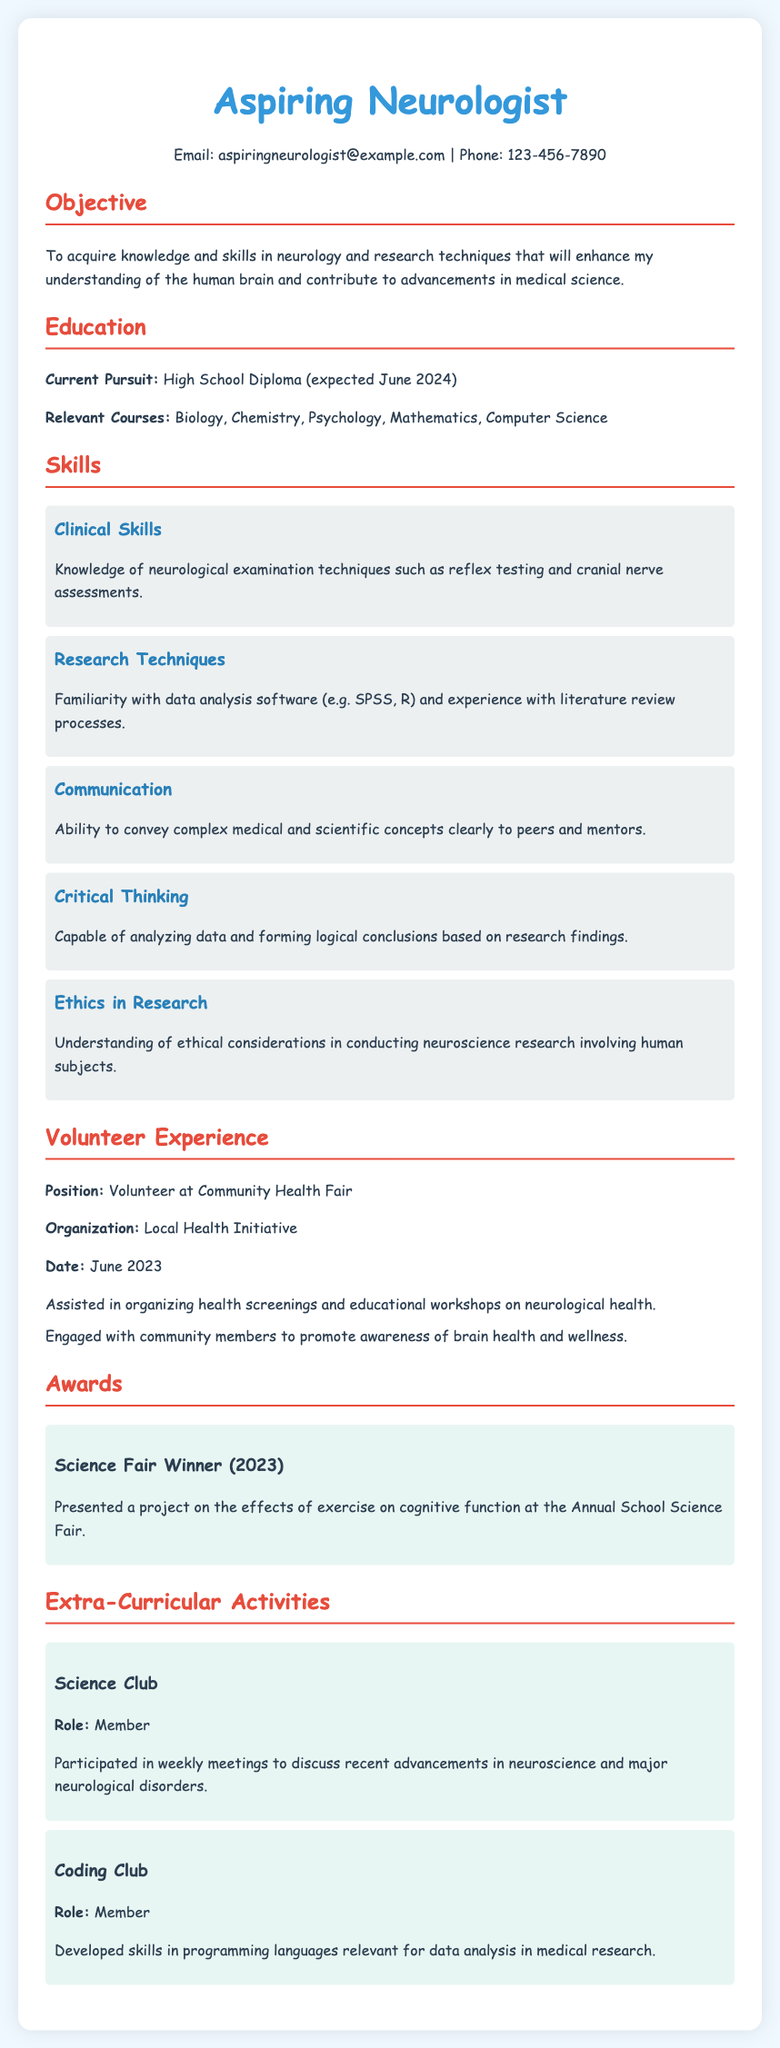what is the email address provided? The email address is listed in the contact information section of the CV.
Answer: aspiringneurologist@example.com what is the expected date of graduation? The expected date of graduation is mentioned under the education section, specifically related to the high school diploma.
Answer: June 2024 which research techniques is mentioned as familiar? The CV lists specific data analysis software known to the aspiring neurologist.
Answer: SPSS, R what kind of volunteer experience is listed? The type of volunteer experience is described in the volunteer experience section.
Answer: Volunteer at Community Health Fair what was the project presented at the Science Fair? The project presented is connected to the effects of a specific activity on cognitive function as applied in a school setting.
Answer: effects of exercise on cognitive function which extracurricular activity involves discussing advancements in neuroscience? The involvement in this activity is specifically focused on a certain club that discusses recent developments.
Answer: Science Club how many awards are listed in the CV? The number of awards mentioned provides insight into the accomplishments recognized in the document.
Answer: One what skill involves conveying complex medical concepts? This skill relates to the aptitude for communication in a medical or scientific context.
Answer: Communication 